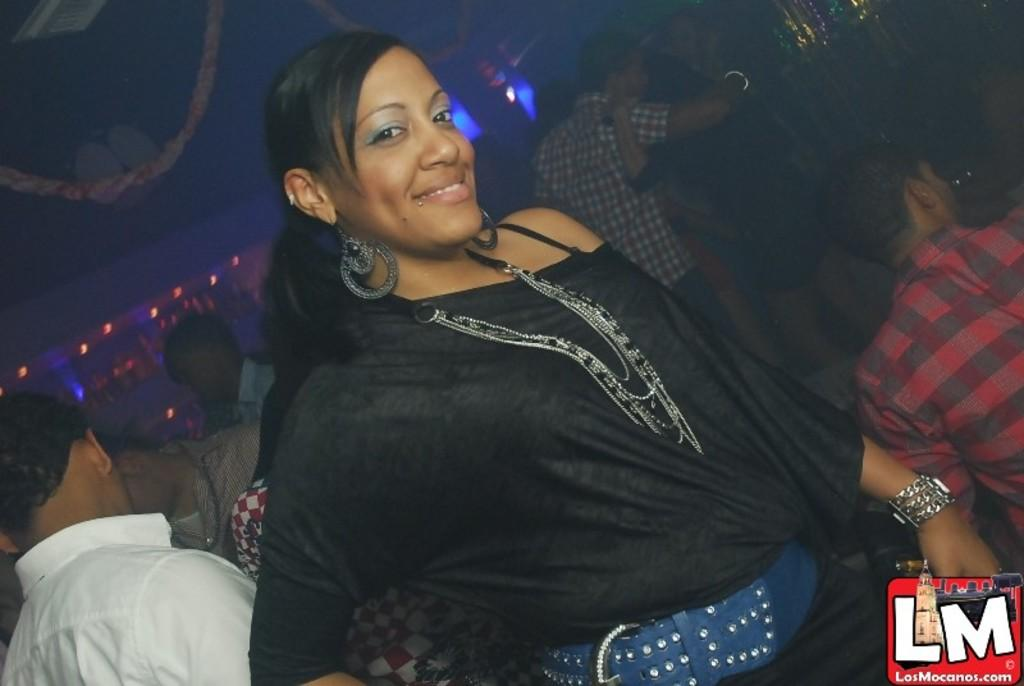What is the main subject of the image? There is a woman in the image. What is the woman doing in the image? The woman is standing in the image. What is the woman's facial expression in the image? The woman is smiling in the image. What can be seen in the background of the image? There are people, lights, and other objects visible in the background of the image. Can you tell me how many cars are parked in the harbor in the image? There is no harbor or cars present in the image; it features a woman standing and smiling with people and lights visible in the background. 